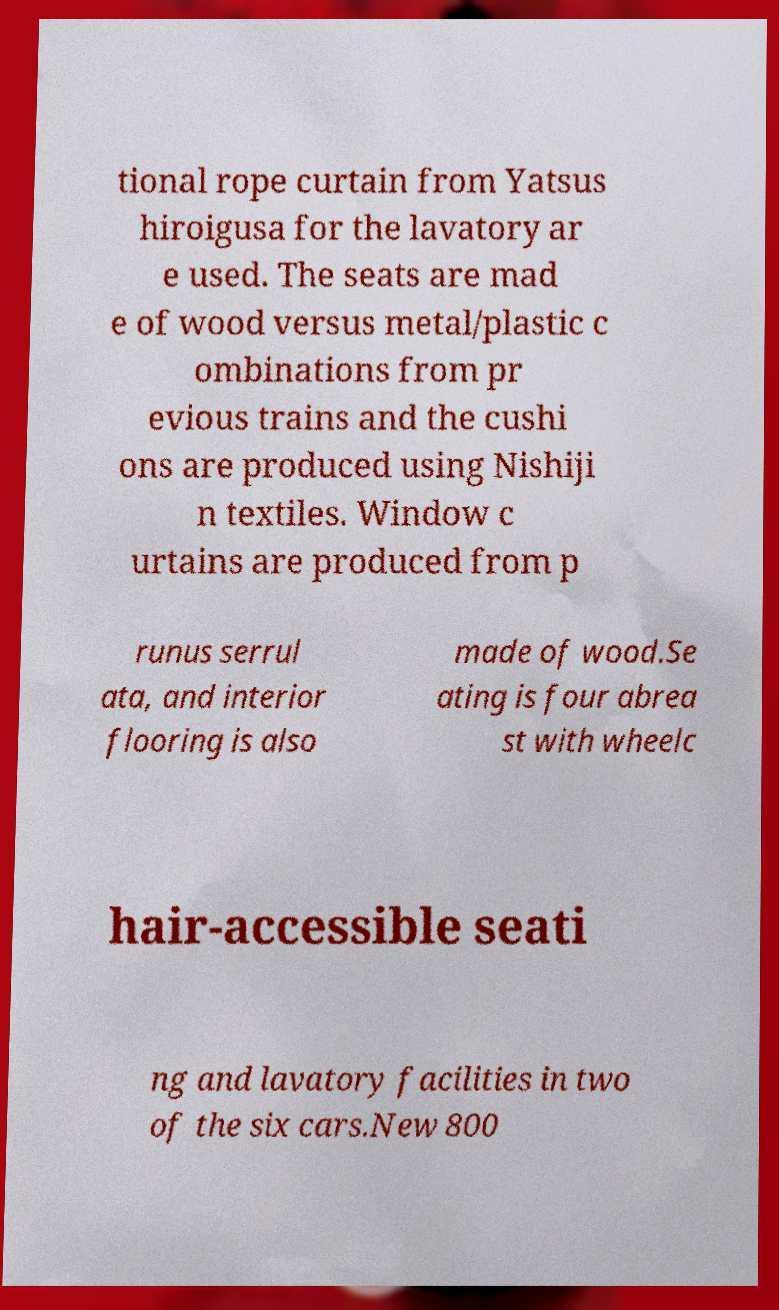What messages or text are displayed in this image? I need them in a readable, typed format. tional rope curtain from Yatsus hiroigusa for the lavatory ar e used. The seats are mad e of wood versus metal/plastic c ombinations from pr evious trains and the cushi ons are produced using Nishiji n textiles. Window c urtains are produced from p runus serrul ata, and interior flooring is also made of wood.Se ating is four abrea st with wheelc hair-accessible seati ng and lavatory facilities in two of the six cars.New 800 